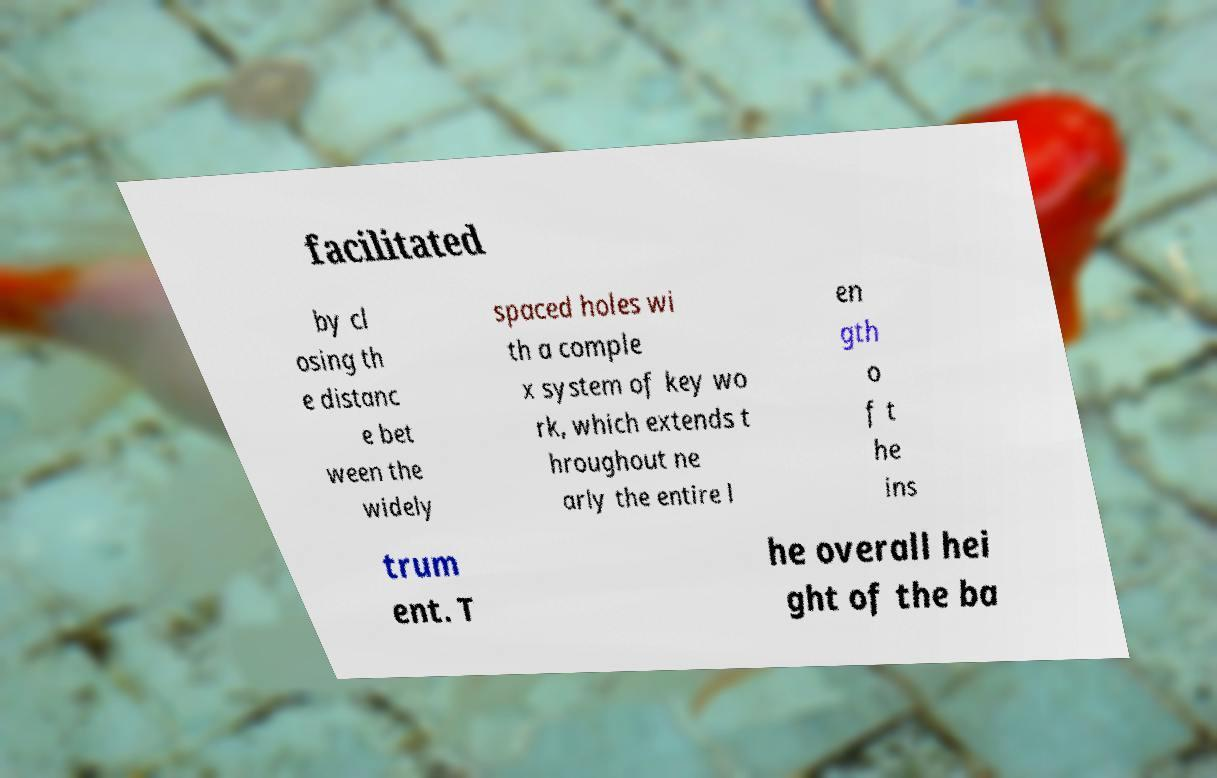There's text embedded in this image that I need extracted. Can you transcribe it verbatim? facilitated by cl osing th e distanc e bet ween the widely spaced holes wi th a comple x system of key wo rk, which extends t hroughout ne arly the entire l en gth o f t he ins trum ent. T he overall hei ght of the ba 